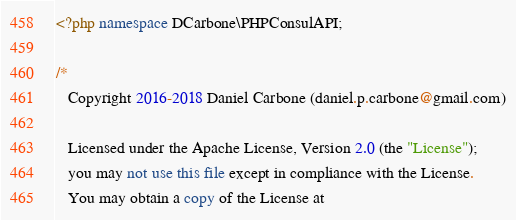Convert code to text. <code><loc_0><loc_0><loc_500><loc_500><_PHP_><?php namespace DCarbone\PHPConsulAPI;

/*
   Copyright 2016-2018 Daniel Carbone (daniel.p.carbone@gmail.com)

   Licensed under the Apache License, Version 2.0 (the "License");
   you may not use this file except in compliance with the License.
   You may obtain a copy of the License at
</code> 